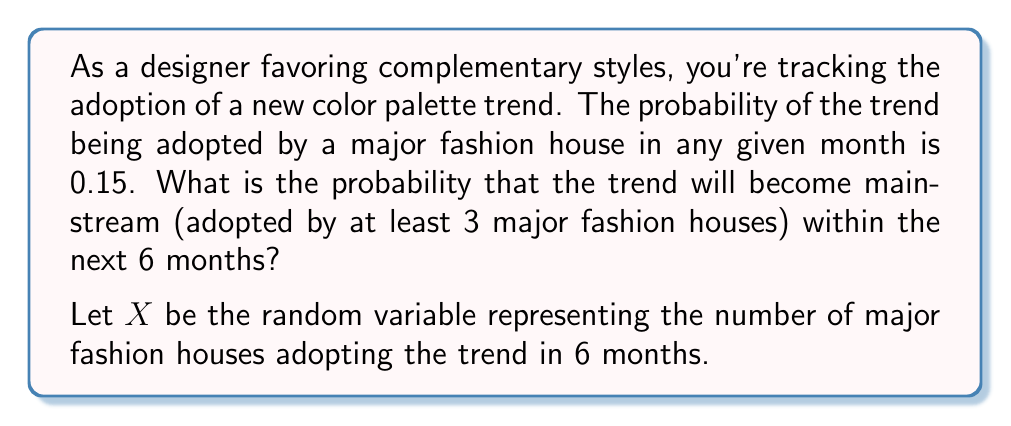Help me with this question. To solve this problem, we can use the Binomial distribution, as we have a fixed number of independent trials (6 months) with a constant probability of success (0.15) for each trial.

1) The probability mass function of the Binomial distribution is:

   $P(X = k) = \binom{n}{k} p^k (1-p)^{n-k}$

   Where:
   $n$ = number of trials (6 months)
   $p$ = probability of success in each trial (0.15)
   $k$ = number of successes

2) We want to find $P(X \geq 3)$, which is equivalent to $1 - P(X < 3)$

3) $P(X < 3) = P(X = 0) + P(X = 1) + P(X = 2)$

4) Let's calculate each probability:

   $P(X = 0) = \binom{6}{0} (0.15)^0 (0.85)^6 = 0.3771$

   $P(X = 1) = \binom{6}{1} (0.15)^1 (0.85)^5 = 0.3993$

   $P(X = 2) = \binom{6}{2} (0.15)^2 (0.85)^4 = 0.1762$

5) Sum these probabilities:

   $P(X < 3) = 0.3771 + 0.3993 + 0.1762 = 0.9526$

6) Therefore, the probability of the trend becoming mainstream (adopted by at least 3 major fashion houses) is:

   $P(X \geq 3) = 1 - P(X < 3) = 1 - 0.9526 = 0.0474$
Answer: The probability that the trend will become mainstream within the next 6 months is approximately 0.0474 or 4.74%. 